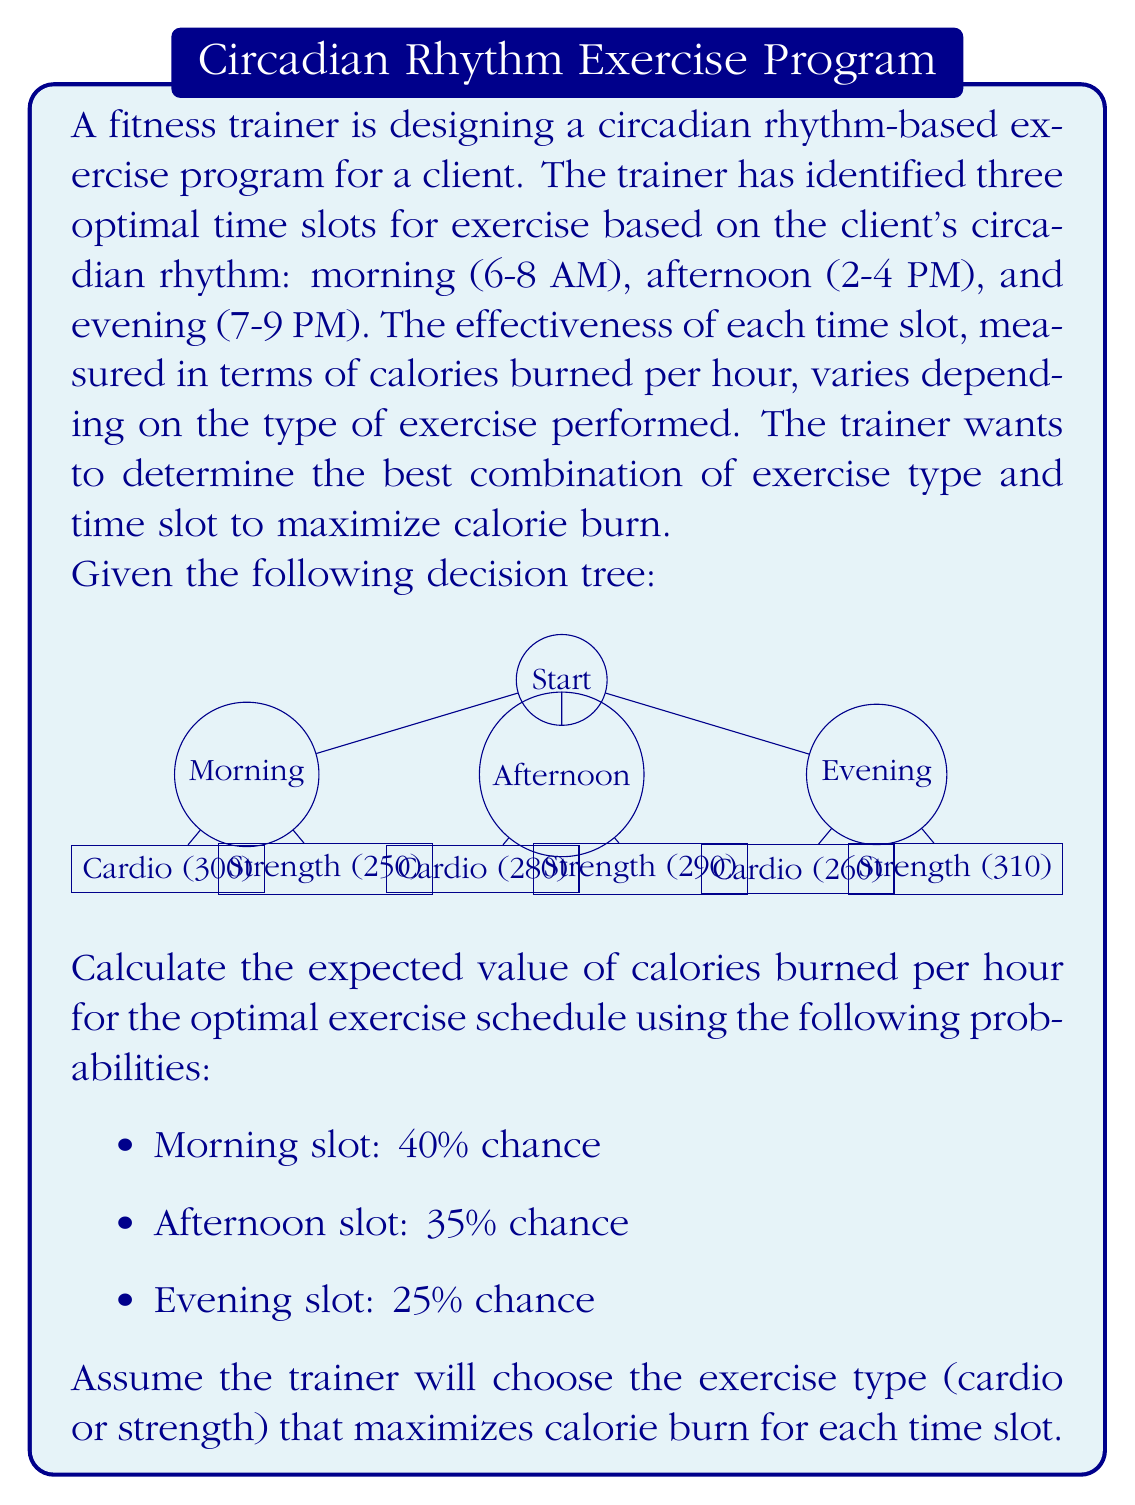What is the answer to this math problem? To solve this problem, we'll use the decision tree and the given probabilities to calculate the expected value of calories burned per hour for the optimal exercise schedule. We'll follow these steps:

1. Identify the optimal exercise type for each time slot.
2. Calculate the maximum calorie burn for each time slot.
3. Compute the expected value using the given probabilities.

Step 1: Identify the optimal exercise type for each time slot

Morning:
- Cardio: 300 calories/hour
- Strength: 250 calories/hour
Optimal: Cardio (300 calories/hour)

Afternoon:
- Cardio: 280 calories/hour
- Strength: 290 calories/hour
Optimal: Strength (290 calories/hour)

Evening:
- Cardio: 260 calories/hour
- Strength: 310 calories/hour
Optimal: Strength (310 calories/hour)

Step 2: Calculate the maximum calorie burn for each time slot

Morning: 300 calories/hour
Afternoon: 290 calories/hour
Evening: 310 calories/hour

Step 3: Compute the expected value using the given probabilities

Let's define the expected value as $E(X)$, where $X$ is the number of calories burned per hour.

$$E(X) = P(\text{Morning}) \times \text{Morning calories} + P(\text{Afternoon}) \times \text{Afternoon calories} + P(\text{Evening}) \times \text{Evening calories}$$

Substituting the values:

$$E(X) = 0.40 \times 300 + 0.35 \times 290 + 0.25 \times 310$$

$$E(X) = 120 + 101.5 + 77.5$$

$$E(X) = 299 \text{ calories/hour}$$

Therefore, the expected value of calories burned per hour for the optimal exercise schedule is 299 calories/hour.
Answer: 299 calories/hour 